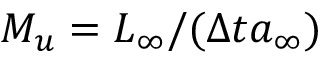Convert formula to latex. <formula><loc_0><loc_0><loc_500><loc_500>M _ { u } = L _ { \infty } / ( \Delta t a _ { \infty } )</formula> 